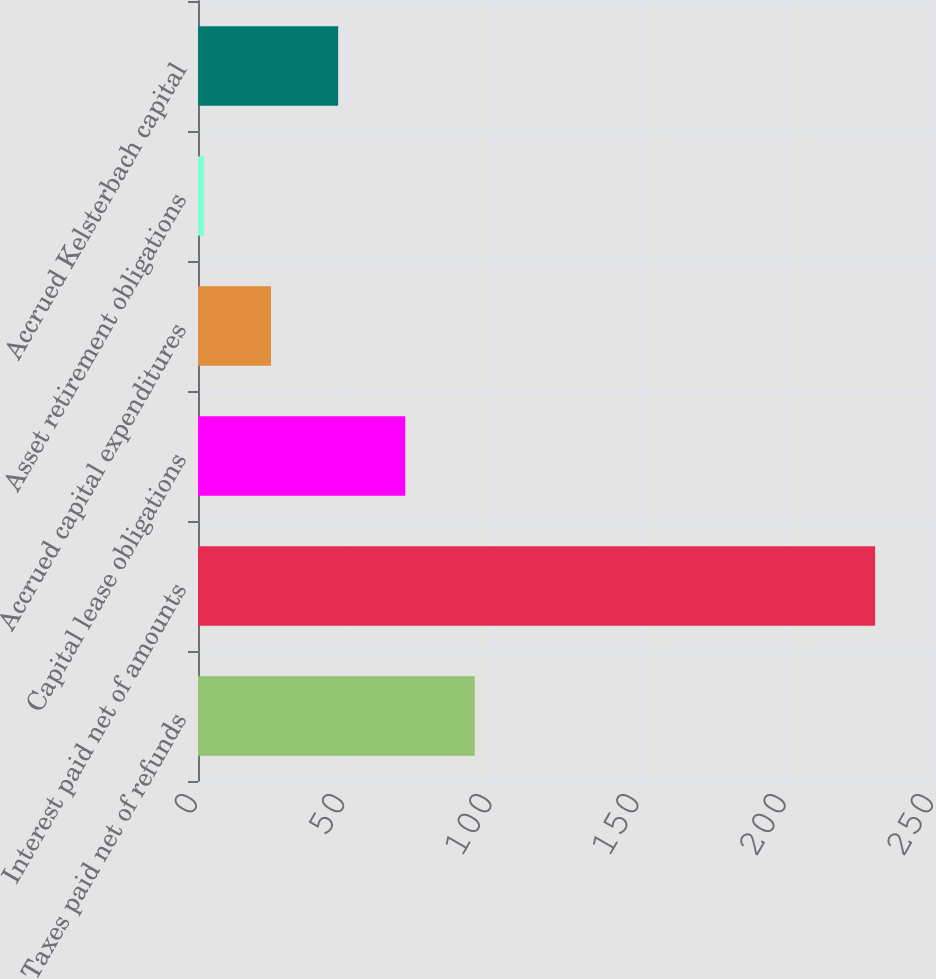Convert chart to OTSL. <chart><loc_0><loc_0><loc_500><loc_500><bar_chart><fcel>Taxes paid net of refunds<fcel>Interest paid net of amounts<fcel>Capital lease obligations<fcel>Accrued capital expenditures<fcel>Asset retirement obligations<fcel>Accrued Kelsterbach capital<nl><fcel>94<fcel>230<fcel>70.4<fcel>24.8<fcel>2<fcel>47.6<nl></chart> 